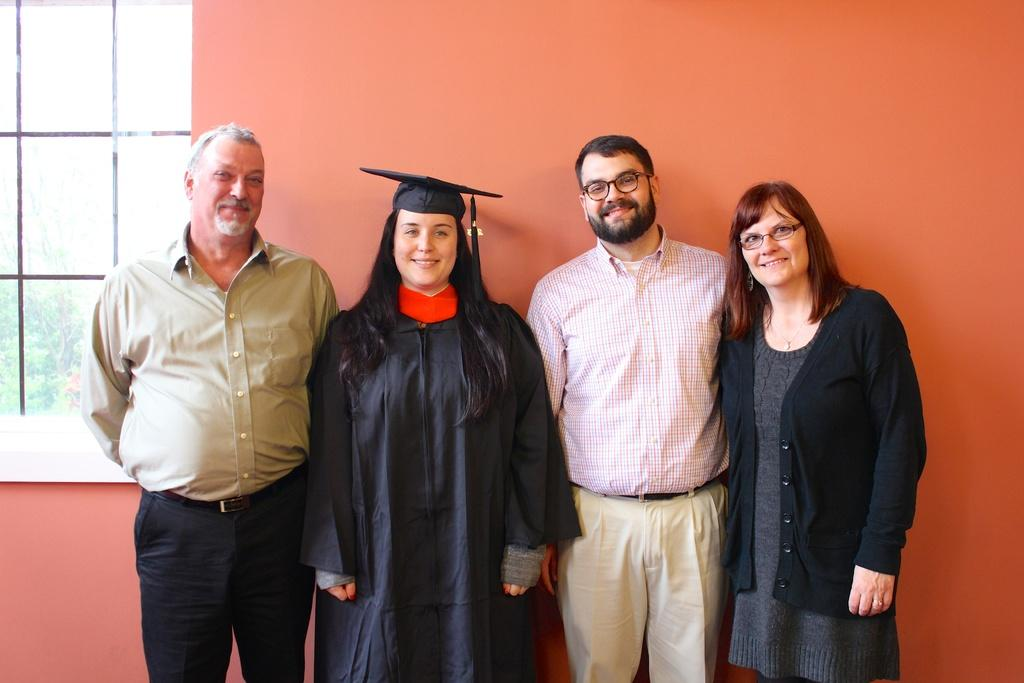What are the people in the image doing? The persons standing in the center of the image are smiling. Can you describe the background of the image? There is a wall and a window in the background of the image. What type of owl can be seen sitting on the person's shoulder in the image? There is no owl present in the image; the persons are standing without any animals. How many thumbs does the person in the image have? The number of thumbs a person has cannot be determined from the image alone, as it only shows the front of the persons. 